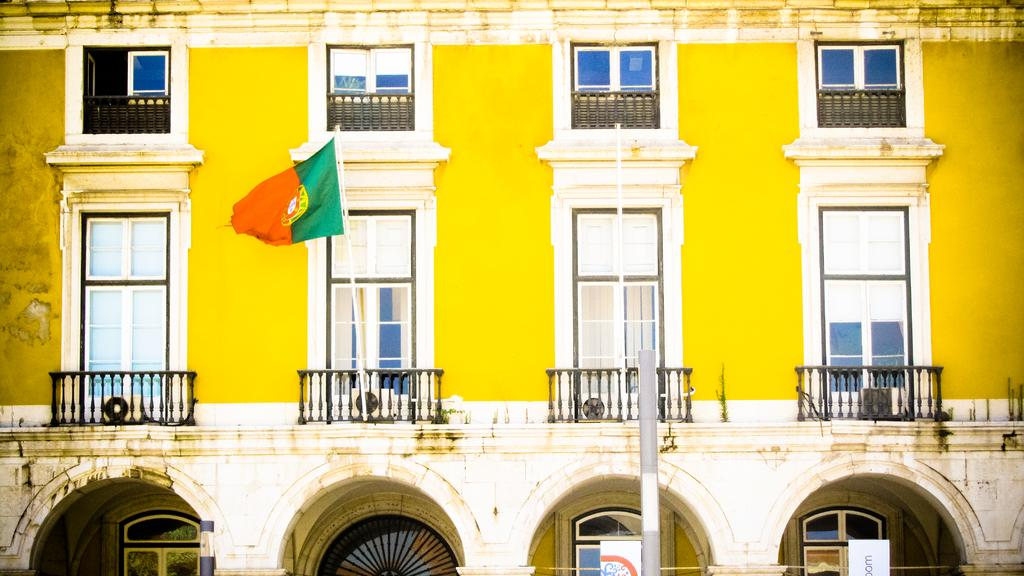What type of structure is visible in the image? There is a building in the image. What can be seen flying near the building? There is a flag in the image. What architectural feature is present in the image? There is a pillar in the image. What type of signage is present in the image? There are two boards with text in the image. How is the glue being used in the image? There is no glue present in the image. What type of list can be seen on the boards with text? The boards with text do not contain a list; they have written text on them. 